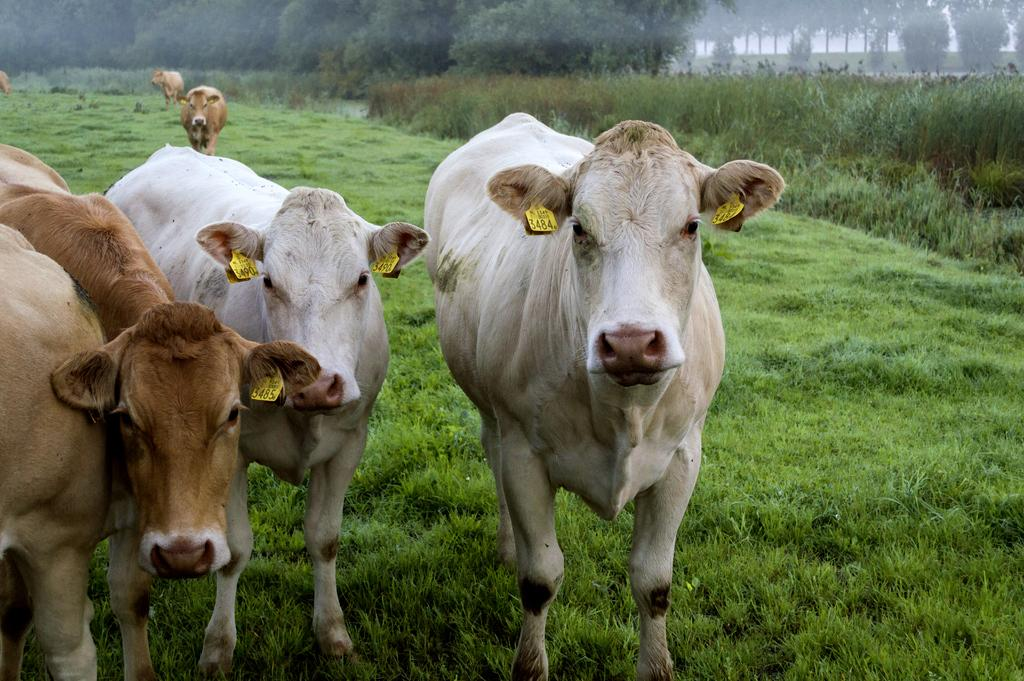Where was the picture taken? The picture was taken outside. What is the main subject in the center of the image? There is a herd of animals in the center of the image. What is the surface the animals are standing on? The animals are standing on the ground. What type of vegetation can be seen in the image? There is green grass, plants, and trees in the image. Can you describe the animals visible in the image? Yes, there are animals visible in the image. What type of skirt is being worn by the tub in the image? There is no tub or skirt present in the image. What color is the nose of the animal in the image? The provided facts do not mention the color of any animal's nose in the image. 